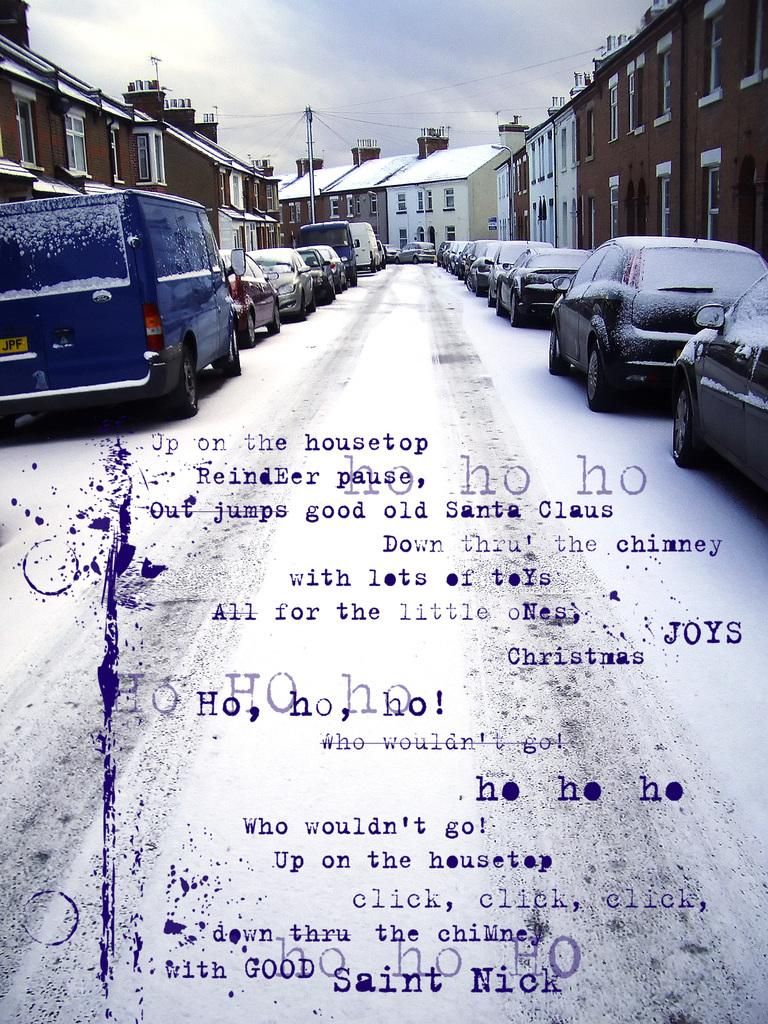What type of structures can be seen in the image? There are buildings in the image. What else is present in the image besides buildings? There are vehicles, text, windows, a pole, and the sky visible in the image. Can you describe the vehicles in the image? The vehicles in the image are not specified, but they are present. What is visible in the background of the image? The sky is visible in the background of the image, and clouds are present in the sky. What type of mask is being worn by the wool in the image? There is no mask or wool present in the image. What activity is taking place during the recess in the image? There is no recess or activity mentioned in the image. 